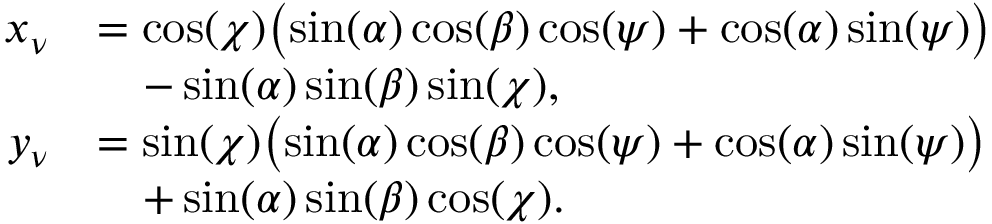Convert formula to latex. <formula><loc_0><loc_0><loc_500><loc_500>\begin{array} { r l } { x _ { \nu } } & { = \cos ( \chi ) \left ( \, \sin ( \alpha ) \cos ( \beta ) \cos ( \psi ) + \cos ( \alpha ) \sin ( \psi ) \right ) } \\ & { \quad - \sin ( \alpha ) \sin ( \beta ) \sin ( \chi ) , } \\ { y _ { \nu } } & { = \sin ( \chi ) \left ( \, \sin ( \alpha ) \cos ( \beta ) \cos ( \psi ) + \cos ( \alpha ) \sin ( \psi ) \right ) } \\ & { \quad + \sin ( \alpha ) \sin ( \beta ) \cos ( \chi ) . } \end{array}</formula> 